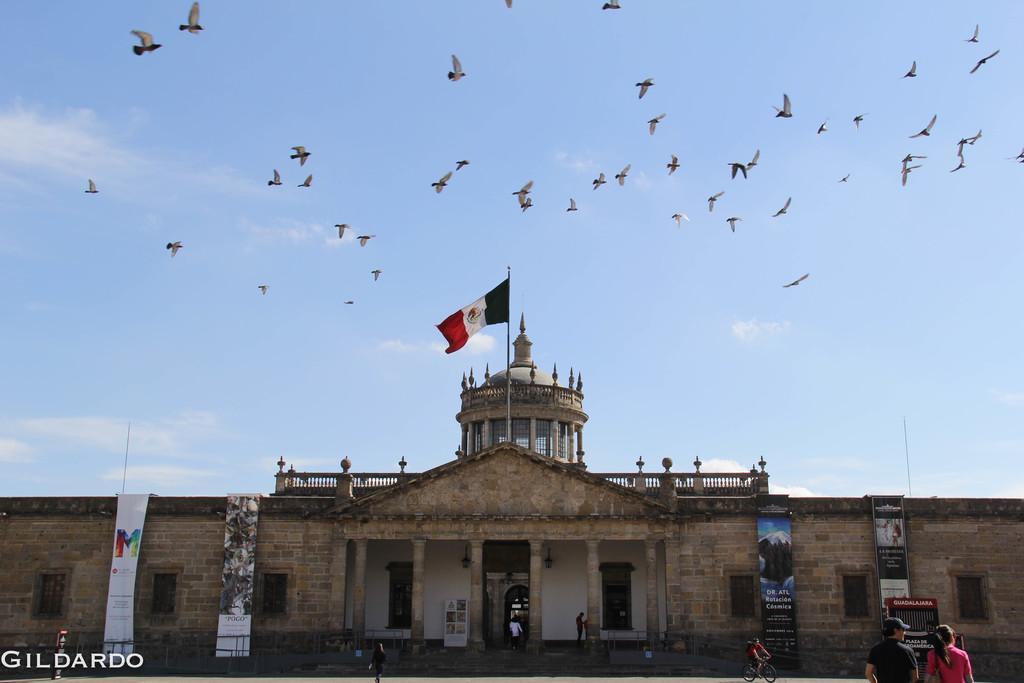Could you give a brief overview of what you see in this image? In the foreground I can see a text, posters, group of people on the road and a fort. In the background I can see flocks of birds and the sky. This image is taken may be during a day near the fort. 